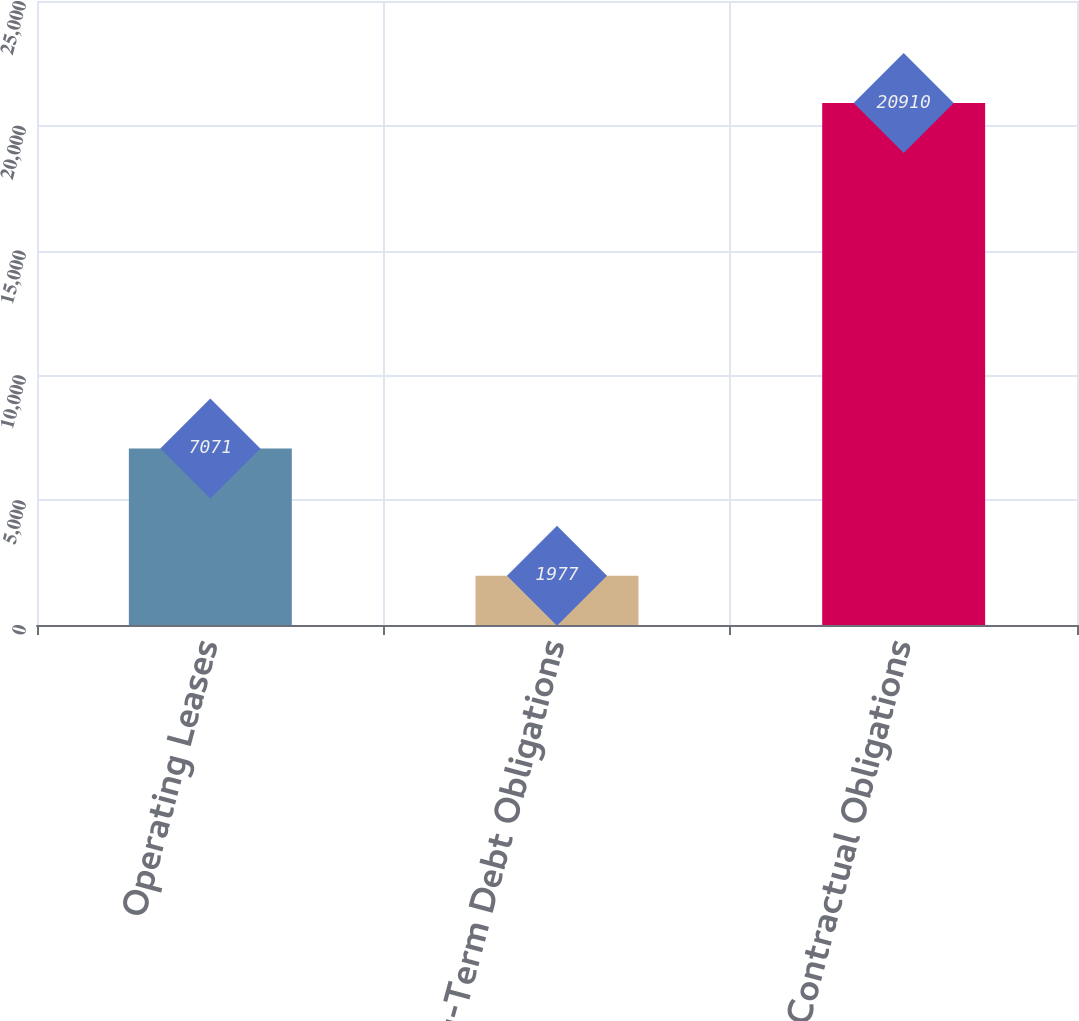Convert chart to OTSL. <chart><loc_0><loc_0><loc_500><loc_500><bar_chart><fcel>Operating Leases<fcel>Long-Term Debt Obligations<fcel>Total Contractual Obligations<nl><fcel>7071<fcel>1977<fcel>20910<nl></chart> 